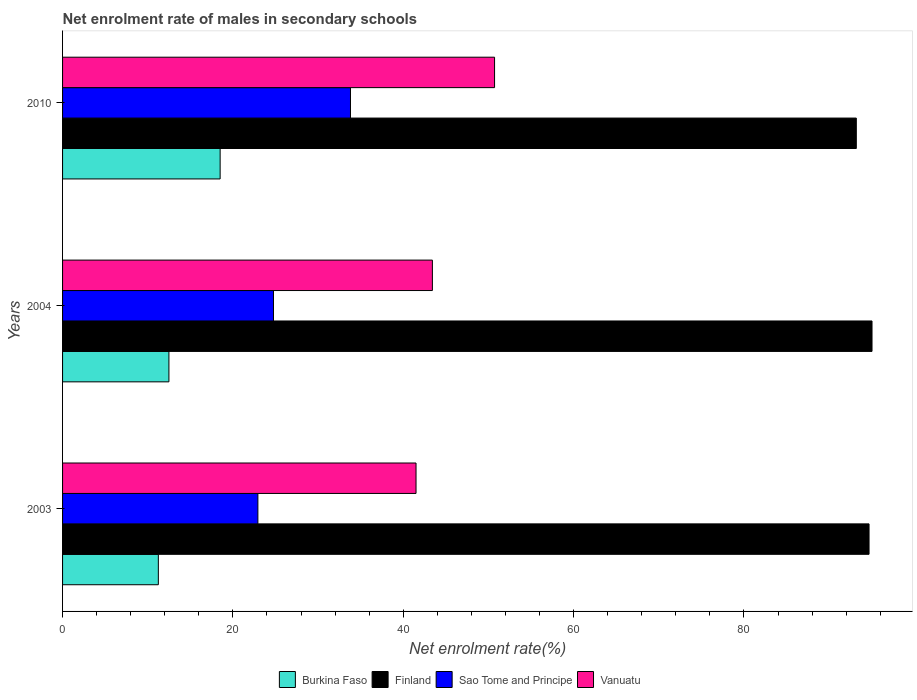How many different coloured bars are there?
Give a very brief answer. 4. How many groups of bars are there?
Your answer should be very brief. 3. Are the number of bars on each tick of the Y-axis equal?
Your response must be concise. Yes. What is the label of the 1st group of bars from the top?
Make the answer very short. 2010. In how many cases, is the number of bars for a given year not equal to the number of legend labels?
Keep it short and to the point. 0. What is the net enrolment rate of males in secondary schools in Sao Tome and Principe in 2004?
Offer a terse response. 24.77. Across all years, what is the maximum net enrolment rate of males in secondary schools in Vanuatu?
Your answer should be very brief. 50.72. Across all years, what is the minimum net enrolment rate of males in secondary schools in Sao Tome and Principe?
Give a very brief answer. 22.93. In which year was the net enrolment rate of males in secondary schools in Sao Tome and Principe maximum?
Your response must be concise. 2010. What is the total net enrolment rate of males in secondary schools in Finland in the graph?
Keep it short and to the point. 282.92. What is the difference between the net enrolment rate of males in secondary schools in Vanuatu in 2004 and that in 2010?
Your answer should be compact. -7.3. What is the difference between the net enrolment rate of males in secondary schools in Sao Tome and Principe in 2010 and the net enrolment rate of males in secondary schools in Burkina Faso in 2003?
Provide a succinct answer. 22.56. What is the average net enrolment rate of males in secondary schools in Sao Tome and Principe per year?
Provide a succinct answer. 27.17. In the year 2003, what is the difference between the net enrolment rate of males in secondary schools in Finland and net enrolment rate of males in secondary schools in Burkina Faso?
Provide a succinct answer. 83.44. What is the ratio of the net enrolment rate of males in secondary schools in Finland in 2003 to that in 2010?
Keep it short and to the point. 1.02. Is the net enrolment rate of males in secondary schools in Sao Tome and Principe in 2004 less than that in 2010?
Ensure brevity in your answer.  Yes. What is the difference between the highest and the second highest net enrolment rate of males in secondary schools in Vanuatu?
Make the answer very short. 7.3. What is the difference between the highest and the lowest net enrolment rate of males in secondary schools in Vanuatu?
Your answer should be very brief. 9.22. In how many years, is the net enrolment rate of males in secondary schools in Burkina Faso greater than the average net enrolment rate of males in secondary schools in Burkina Faso taken over all years?
Ensure brevity in your answer.  1. What does the 3rd bar from the top in 2003 represents?
Provide a succinct answer. Finland. Is it the case that in every year, the sum of the net enrolment rate of males in secondary schools in Sao Tome and Principe and net enrolment rate of males in secondary schools in Burkina Faso is greater than the net enrolment rate of males in secondary schools in Vanuatu?
Provide a short and direct response. No. How many bars are there?
Give a very brief answer. 12. What is the difference between two consecutive major ticks on the X-axis?
Keep it short and to the point. 20. Are the values on the major ticks of X-axis written in scientific E-notation?
Your response must be concise. No. Where does the legend appear in the graph?
Offer a very short reply. Bottom center. How are the legend labels stacked?
Offer a terse response. Horizontal. What is the title of the graph?
Your response must be concise. Net enrolment rate of males in secondary schools. Does "Brazil" appear as one of the legend labels in the graph?
Ensure brevity in your answer.  No. What is the label or title of the X-axis?
Offer a very short reply. Net enrolment rate(%). What is the label or title of the Y-axis?
Your answer should be very brief. Years. What is the Net enrolment rate(%) in Burkina Faso in 2003?
Ensure brevity in your answer.  11.25. What is the Net enrolment rate(%) in Finland in 2003?
Provide a short and direct response. 94.69. What is the Net enrolment rate(%) of Sao Tome and Principe in 2003?
Your answer should be compact. 22.93. What is the Net enrolment rate(%) of Vanuatu in 2003?
Provide a short and direct response. 41.5. What is the Net enrolment rate(%) of Burkina Faso in 2004?
Ensure brevity in your answer.  12.49. What is the Net enrolment rate(%) of Finland in 2004?
Offer a terse response. 95.04. What is the Net enrolment rate(%) in Sao Tome and Principe in 2004?
Keep it short and to the point. 24.77. What is the Net enrolment rate(%) in Vanuatu in 2004?
Offer a very short reply. 43.42. What is the Net enrolment rate(%) in Burkina Faso in 2010?
Give a very brief answer. 18.5. What is the Net enrolment rate(%) of Finland in 2010?
Ensure brevity in your answer.  93.19. What is the Net enrolment rate(%) of Sao Tome and Principe in 2010?
Make the answer very short. 33.8. What is the Net enrolment rate(%) of Vanuatu in 2010?
Provide a succinct answer. 50.72. Across all years, what is the maximum Net enrolment rate(%) of Burkina Faso?
Offer a terse response. 18.5. Across all years, what is the maximum Net enrolment rate(%) in Finland?
Make the answer very short. 95.04. Across all years, what is the maximum Net enrolment rate(%) of Sao Tome and Principe?
Your response must be concise. 33.8. Across all years, what is the maximum Net enrolment rate(%) in Vanuatu?
Ensure brevity in your answer.  50.72. Across all years, what is the minimum Net enrolment rate(%) of Burkina Faso?
Your response must be concise. 11.25. Across all years, what is the minimum Net enrolment rate(%) in Finland?
Your response must be concise. 93.19. Across all years, what is the minimum Net enrolment rate(%) in Sao Tome and Principe?
Provide a short and direct response. 22.93. Across all years, what is the minimum Net enrolment rate(%) in Vanuatu?
Provide a short and direct response. 41.5. What is the total Net enrolment rate(%) in Burkina Faso in the graph?
Your answer should be very brief. 42.23. What is the total Net enrolment rate(%) in Finland in the graph?
Ensure brevity in your answer.  282.92. What is the total Net enrolment rate(%) of Sao Tome and Principe in the graph?
Your answer should be compact. 81.5. What is the total Net enrolment rate(%) in Vanuatu in the graph?
Your response must be concise. 135.64. What is the difference between the Net enrolment rate(%) in Burkina Faso in 2003 and that in 2004?
Your response must be concise. -1.24. What is the difference between the Net enrolment rate(%) in Finland in 2003 and that in 2004?
Provide a short and direct response. -0.35. What is the difference between the Net enrolment rate(%) in Sao Tome and Principe in 2003 and that in 2004?
Your answer should be very brief. -1.83. What is the difference between the Net enrolment rate(%) in Vanuatu in 2003 and that in 2004?
Provide a short and direct response. -1.92. What is the difference between the Net enrolment rate(%) in Burkina Faso in 2003 and that in 2010?
Your response must be concise. -7.26. What is the difference between the Net enrolment rate(%) of Finland in 2003 and that in 2010?
Your response must be concise. 1.5. What is the difference between the Net enrolment rate(%) in Sao Tome and Principe in 2003 and that in 2010?
Ensure brevity in your answer.  -10.87. What is the difference between the Net enrolment rate(%) in Vanuatu in 2003 and that in 2010?
Keep it short and to the point. -9.22. What is the difference between the Net enrolment rate(%) in Burkina Faso in 2004 and that in 2010?
Provide a succinct answer. -6.01. What is the difference between the Net enrolment rate(%) in Finland in 2004 and that in 2010?
Offer a very short reply. 1.84. What is the difference between the Net enrolment rate(%) in Sao Tome and Principe in 2004 and that in 2010?
Your response must be concise. -9.04. What is the difference between the Net enrolment rate(%) of Vanuatu in 2004 and that in 2010?
Provide a short and direct response. -7.3. What is the difference between the Net enrolment rate(%) in Burkina Faso in 2003 and the Net enrolment rate(%) in Finland in 2004?
Offer a very short reply. -83.79. What is the difference between the Net enrolment rate(%) in Burkina Faso in 2003 and the Net enrolment rate(%) in Sao Tome and Principe in 2004?
Your answer should be very brief. -13.52. What is the difference between the Net enrolment rate(%) in Burkina Faso in 2003 and the Net enrolment rate(%) in Vanuatu in 2004?
Offer a very short reply. -32.18. What is the difference between the Net enrolment rate(%) of Finland in 2003 and the Net enrolment rate(%) of Sao Tome and Principe in 2004?
Provide a succinct answer. 69.92. What is the difference between the Net enrolment rate(%) in Finland in 2003 and the Net enrolment rate(%) in Vanuatu in 2004?
Provide a succinct answer. 51.27. What is the difference between the Net enrolment rate(%) of Sao Tome and Principe in 2003 and the Net enrolment rate(%) of Vanuatu in 2004?
Make the answer very short. -20.49. What is the difference between the Net enrolment rate(%) in Burkina Faso in 2003 and the Net enrolment rate(%) in Finland in 2010?
Your answer should be very brief. -81.95. What is the difference between the Net enrolment rate(%) of Burkina Faso in 2003 and the Net enrolment rate(%) of Sao Tome and Principe in 2010?
Offer a terse response. -22.56. What is the difference between the Net enrolment rate(%) in Burkina Faso in 2003 and the Net enrolment rate(%) in Vanuatu in 2010?
Make the answer very short. -39.48. What is the difference between the Net enrolment rate(%) in Finland in 2003 and the Net enrolment rate(%) in Sao Tome and Principe in 2010?
Your answer should be compact. 60.88. What is the difference between the Net enrolment rate(%) in Finland in 2003 and the Net enrolment rate(%) in Vanuatu in 2010?
Your answer should be very brief. 43.97. What is the difference between the Net enrolment rate(%) in Sao Tome and Principe in 2003 and the Net enrolment rate(%) in Vanuatu in 2010?
Give a very brief answer. -27.79. What is the difference between the Net enrolment rate(%) in Burkina Faso in 2004 and the Net enrolment rate(%) in Finland in 2010?
Offer a very short reply. -80.71. What is the difference between the Net enrolment rate(%) in Burkina Faso in 2004 and the Net enrolment rate(%) in Sao Tome and Principe in 2010?
Keep it short and to the point. -21.32. What is the difference between the Net enrolment rate(%) of Burkina Faso in 2004 and the Net enrolment rate(%) of Vanuatu in 2010?
Your answer should be compact. -38.23. What is the difference between the Net enrolment rate(%) in Finland in 2004 and the Net enrolment rate(%) in Sao Tome and Principe in 2010?
Offer a very short reply. 61.23. What is the difference between the Net enrolment rate(%) of Finland in 2004 and the Net enrolment rate(%) of Vanuatu in 2010?
Keep it short and to the point. 44.32. What is the difference between the Net enrolment rate(%) of Sao Tome and Principe in 2004 and the Net enrolment rate(%) of Vanuatu in 2010?
Offer a terse response. -25.96. What is the average Net enrolment rate(%) of Burkina Faso per year?
Offer a terse response. 14.08. What is the average Net enrolment rate(%) in Finland per year?
Keep it short and to the point. 94.31. What is the average Net enrolment rate(%) of Sao Tome and Principe per year?
Offer a very short reply. 27.17. What is the average Net enrolment rate(%) in Vanuatu per year?
Provide a short and direct response. 45.21. In the year 2003, what is the difference between the Net enrolment rate(%) of Burkina Faso and Net enrolment rate(%) of Finland?
Provide a short and direct response. -83.44. In the year 2003, what is the difference between the Net enrolment rate(%) in Burkina Faso and Net enrolment rate(%) in Sao Tome and Principe?
Your answer should be compact. -11.69. In the year 2003, what is the difference between the Net enrolment rate(%) of Burkina Faso and Net enrolment rate(%) of Vanuatu?
Offer a terse response. -30.26. In the year 2003, what is the difference between the Net enrolment rate(%) of Finland and Net enrolment rate(%) of Sao Tome and Principe?
Give a very brief answer. 71.76. In the year 2003, what is the difference between the Net enrolment rate(%) of Finland and Net enrolment rate(%) of Vanuatu?
Your answer should be compact. 53.19. In the year 2003, what is the difference between the Net enrolment rate(%) in Sao Tome and Principe and Net enrolment rate(%) in Vanuatu?
Your response must be concise. -18.57. In the year 2004, what is the difference between the Net enrolment rate(%) of Burkina Faso and Net enrolment rate(%) of Finland?
Your answer should be compact. -82.55. In the year 2004, what is the difference between the Net enrolment rate(%) of Burkina Faso and Net enrolment rate(%) of Sao Tome and Principe?
Your answer should be compact. -12.28. In the year 2004, what is the difference between the Net enrolment rate(%) in Burkina Faso and Net enrolment rate(%) in Vanuatu?
Keep it short and to the point. -30.93. In the year 2004, what is the difference between the Net enrolment rate(%) in Finland and Net enrolment rate(%) in Sao Tome and Principe?
Give a very brief answer. 70.27. In the year 2004, what is the difference between the Net enrolment rate(%) in Finland and Net enrolment rate(%) in Vanuatu?
Provide a short and direct response. 51.62. In the year 2004, what is the difference between the Net enrolment rate(%) in Sao Tome and Principe and Net enrolment rate(%) in Vanuatu?
Your answer should be very brief. -18.66. In the year 2010, what is the difference between the Net enrolment rate(%) in Burkina Faso and Net enrolment rate(%) in Finland?
Keep it short and to the point. -74.69. In the year 2010, what is the difference between the Net enrolment rate(%) in Burkina Faso and Net enrolment rate(%) in Sao Tome and Principe?
Give a very brief answer. -15.3. In the year 2010, what is the difference between the Net enrolment rate(%) in Burkina Faso and Net enrolment rate(%) in Vanuatu?
Provide a succinct answer. -32.22. In the year 2010, what is the difference between the Net enrolment rate(%) in Finland and Net enrolment rate(%) in Sao Tome and Principe?
Your answer should be very brief. 59.39. In the year 2010, what is the difference between the Net enrolment rate(%) of Finland and Net enrolment rate(%) of Vanuatu?
Provide a short and direct response. 42.47. In the year 2010, what is the difference between the Net enrolment rate(%) in Sao Tome and Principe and Net enrolment rate(%) in Vanuatu?
Offer a terse response. -16.92. What is the ratio of the Net enrolment rate(%) of Burkina Faso in 2003 to that in 2004?
Your answer should be very brief. 0.9. What is the ratio of the Net enrolment rate(%) in Finland in 2003 to that in 2004?
Offer a terse response. 1. What is the ratio of the Net enrolment rate(%) of Sao Tome and Principe in 2003 to that in 2004?
Your response must be concise. 0.93. What is the ratio of the Net enrolment rate(%) in Vanuatu in 2003 to that in 2004?
Your answer should be compact. 0.96. What is the ratio of the Net enrolment rate(%) of Burkina Faso in 2003 to that in 2010?
Give a very brief answer. 0.61. What is the ratio of the Net enrolment rate(%) of Sao Tome and Principe in 2003 to that in 2010?
Your answer should be compact. 0.68. What is the ratio of the Net enrolment rate(%) of Vanuatu in 2003 to that in 2010?
Your answer should be compact. 0.82. What is the ratio of the Net enrolment rate(%) of Burkina Faso in 2004 to that in 2010?
Provide a short and direct response. 0.68. What is the ratio of the Net enrolment rate(%) of Finland in 2004 to that in 2010?
Your response must be concise. 1.02. What is the ratio of the Net enrolment rate(%) in Sao Tome and Principe in 2004 to that in 2010?
Your answer should be very brief. 0.73. What is the ratio of the Net enrolment rate(%) in Vanuatu in 2004 to that in 2010?
Give a very brief answer. 0.86. What is the difference between the highest and the second highest Net enrolment rate(%) of Burkina Faso?
Your response must be concise. 6.01. What is the difference between the highest and the second highest Net enrolment rate(%) in Finland?
Ensure brevity in your answer.  0.35. What is the difference between the highest and the second highest Net enrolment rate(%) of Sao Tome and Principe?
Your answer should be compact. 9.04. What is the difference between the highest and the second highest Net enrolment rate(%) of Vanuatu?
Offer a terse response. 7.3. What is the difference between the highest and the lowest Net enrolment rate(%) in Burkina Faso?
Ensure brevity in your answer.  7.26. What is the difference between the highest and the lowest Net enrolment rate(%) of Finland?
Give a very brief answer. 1.84. What is the difference between the highest and the lowest Net enrolment rate(%) in Sao Tome and Principe?
Ensure brevity in your answer.  10.87. What is the difference between the highest and the lowest Net enrolment rate(%) of Vanuatu?
Offer a terse response. 9.22. 